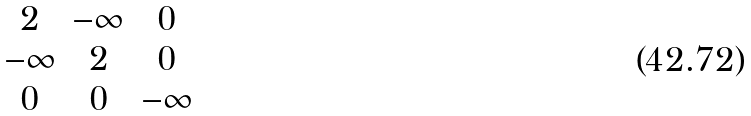Convert formula to latex. <formula><loc_0><loc_0><loc_500><loc_500>\begin{matrix} 2 & - \infty & 0 \\ - \infty & 2 & 0 \\ 0 & 0 & - \infty \end{matrix}</formula> 